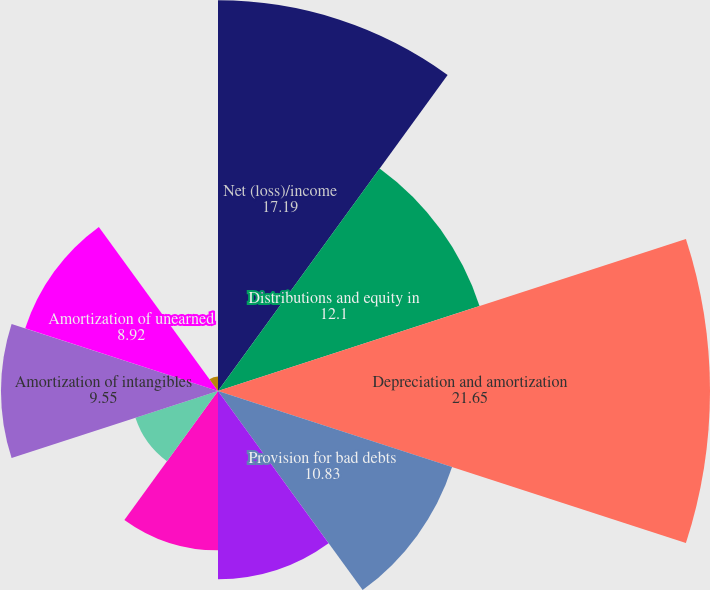Convert chart. <chart><loc_0><loc_0><loc_500><loc_500><pie_chart><fcel>Net (loss)/income<fcel>Distributions and equity in<fcel>Depreciation and amortization<fcel>Provision for bad debts<fcel>Amortization of nuclear fuel<fcel>Amortization of financing<fcel>Adjustment to loss on debt<fcel>Amortization of intangibles<fcel>Amortization of unearned<fcel>(Gain)/Loss on disposals and<nl><fcel>17.19%<fcel>12.1%<fcel>21.65%<fcel>10.83%<fcel>8.28%<fcel>7.01%<fcel>3.82%<fcel>9.55%<fcel>8.92%<fcel>0.64%<nl></chart> 